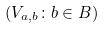<formula> <loc_0><loc_0><loc_500><loc_500>( V _ { a , b } \colon b \in B )</formula> 